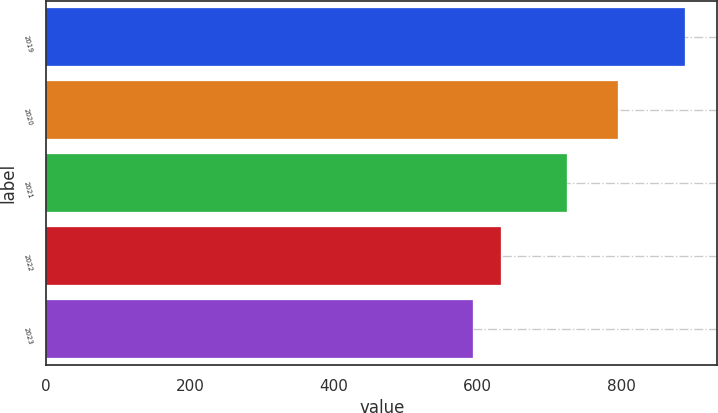Convert chart. <chart><loc_0><loc_0><loc_500><loc_500><bar_chart><fcel>2019<fcel>2020<fcel>2021<fcel>2022<fcel>2023<nl><fcel>889<fcel>795<fcel>724<fcel>632<fcel>593<nl></chart> 